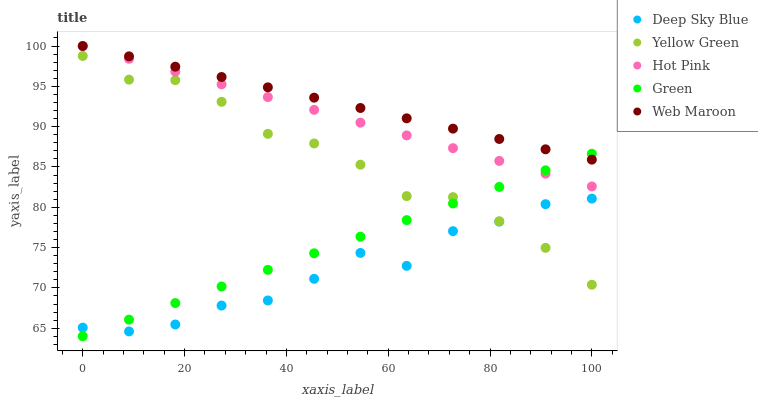Does Deep Sky Blue have the minimum area under the curve?
Answer yes or no. Yes. Does Web Maroon have the maximum area under the curve?
Answer yes or no. Yes. Does Hot Pink have the minimum area under the curve?
Answer yes or no. No. Does Hot Pink have the maximum area under the curve?
Answer yes or no. No. Is Web Maroon the smoothest?
Answer yes or no. Yes. Is Deep Sky Blue the roughest?
Answer yes or no. Yes. Is Hot Pink the smoothest?
Answer yes or no. No. Is Hot Pink the roughest?
Answer yes or no. No. Does Green have the lowest value?
Answer yes or no. Yes. Does Hot Pink have the lowest value?
Answer yes or no. No. Does Hot Pink have the highest value?
Answer yes or no. Yes. Does Green have the highest value?
Answer yes or no. No. Is Deep Sky Blue less than Hot Pink?
Answer yes or no. Yes. Is Web Maroon greater than Yellow Green?
Answer yes or no. Yes. Does Web Maroon intersect Green?
Answer yes or no. Yes. Is Web Maroon less than Green?
Answer yes or no. No. Is Web Maroon greater than Green?
Answer yes or no. No. Does Deep Sky Blue intersect Hot Pink?
Answer yes or no. No. 